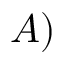<formula> <loc_0><loc_0><loc_500><loc_500>A )</formula> 